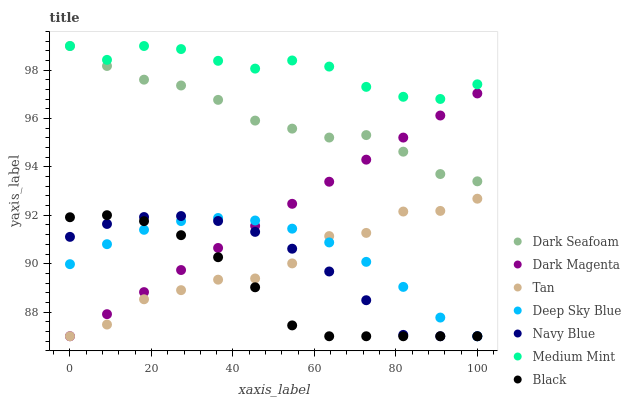Does Black have the minimum area under the curve?
Answer yes or no. Yes. Does Medium Mint have the maximum area under the curve?
Answer yes or no. Yes. Does Dark Magenta have the minimum area under the curve?
Answer yes or no. No. Does Dark Magenta have the maximum area under the curve?
Answer yes or no. No. Is Dark Magenta the smoothest?
Answer yes or no. Yes. Is Tan the roughest?
Answer yes or no. Yes. Is Navy Blue the smoothest?
Answer yes or no. No. Is Navy Blue the roughest?
Answer yes or no. No. Does Dark Magenta have the lowest value?
Answer yes or no. Yes. Does Dark Seafoam have the lowest value?
Answer yes or no. No. Does Dark Seafoam have the highest value?
Answer yes or no. Yes. Does Dark Magenta have the highest value?
Answer yes or no. No. Is Dark Magenta less than Medium Mint?
Answer yes or no. Yes. Is Dark Seafoam greater than Black?
Answer yes or no. Yes. Does Dark Magenta intersect Black?
Answer yes or no. Yes. Is Dark Magenta less than Black?
Answer yes or no. No. Is Dark Magenta greater than Black?
Answer yes or no. No. Does Dark Magenta intersect Medium Mint?
Answer yes or no. No. 